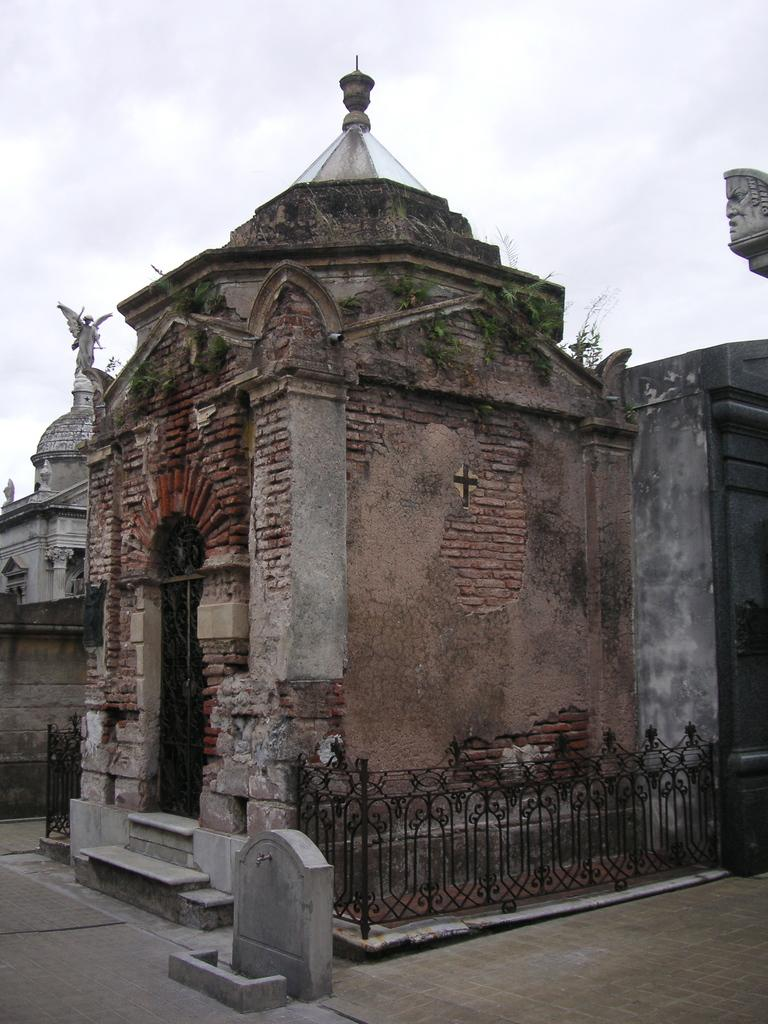What type of structures can be seen in the image? There are architectures in the image. What is visible in the foreground of the image? There is a floor visible in the foreground of the image. How many loaves of bread can be seen on the floor in the image? There are no loaves of bread present in the image; it only features architectures and a floor. What type of connection can be seen between the architectures in the image? The provided facts do not mention any specific connections between the architectures, so it cannot be determined from the image. 